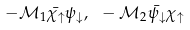Convert formula to latex. <formula><loc_0><loc_0><loc_500><loc_500>- \mathcal { M } _ { 1 } \bar { \chi _ { \uparrow } } \psi _ { \downarrow } , { \, } { \, } { \, } - \mathcal { M } _ { 2 } \bar { \psi _ { \downarrow } } \chi _ { \uparrow }</formula> 